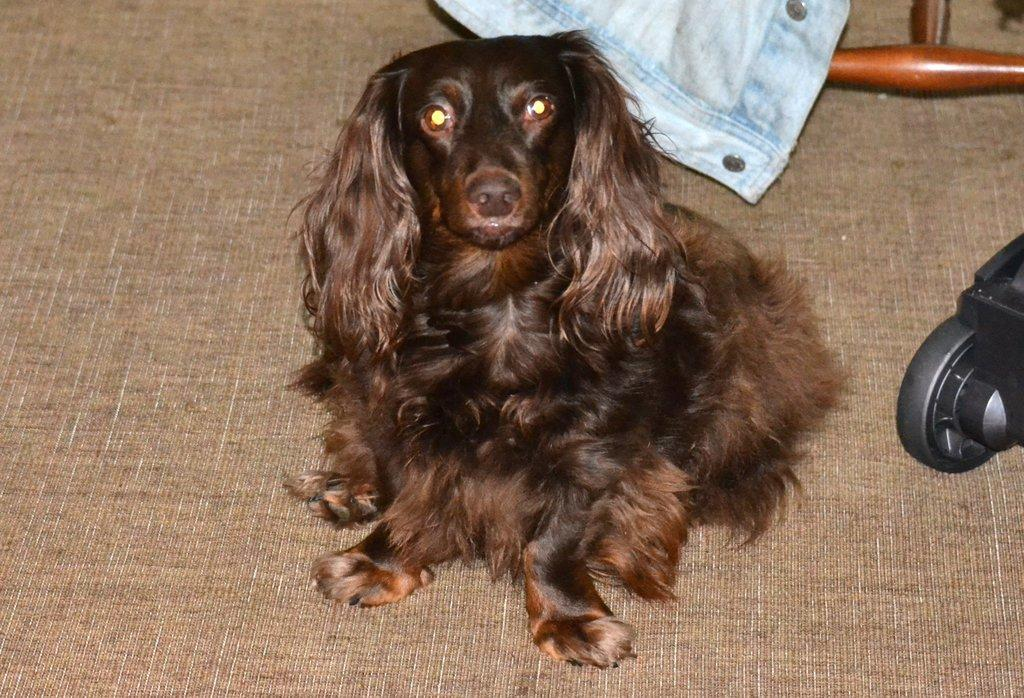What type of animal is in the image? There is a dog in the image. Where is the dog located? The dog is on a platform. What can be seen in the background of the image? There are objects visible in the background of the image. How many clovers can be seen in the image? There are no clovers present in the image. What type of food is the dog eating in the image? The provided facts do not mention any food in the image, so we cannot determine what the dog might be eating. 